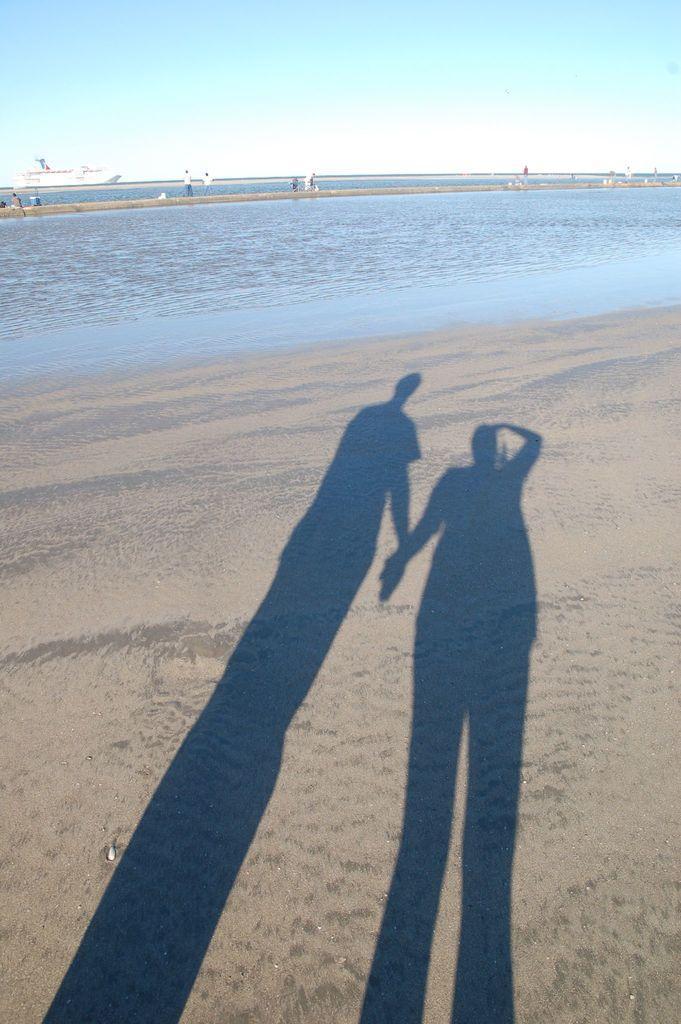Describe this image in one or two sentences. In this image, I can see the shadow of two people standing. In the background, that looks like a ship on the water. There are few people standing. This is the sea. 